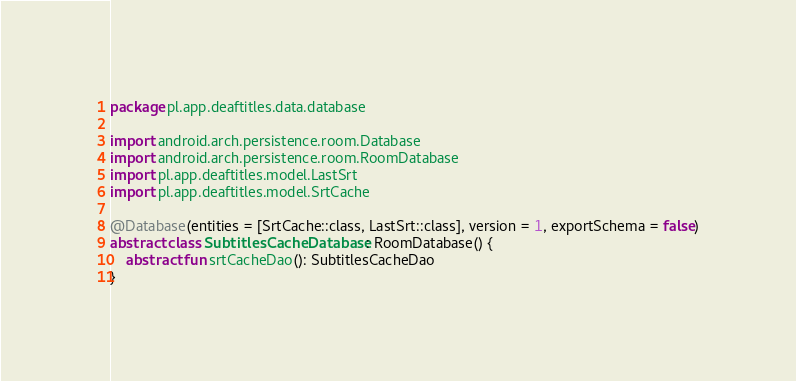<code> <loc_0><loc_0><loc_500><loc_500><_Kotlin_>package pl.app.deaftitles.data.database

import android.arch.persistence.room.Database
import android.arch.persistence.room.RoomDatabase
import pl.app.deaftitles.model.LastSrt
import pl.app.deaftitles.model.SrtCache

@Database(entities = [SrtCache::class, LastSrt::class], version = 1, exportSchema = false)
abstract class SubtitlesCacheDatabase : RoomDatabase() {
    abstract fun srtCacheDao(): SubtitlesCacheDao
}</code> 